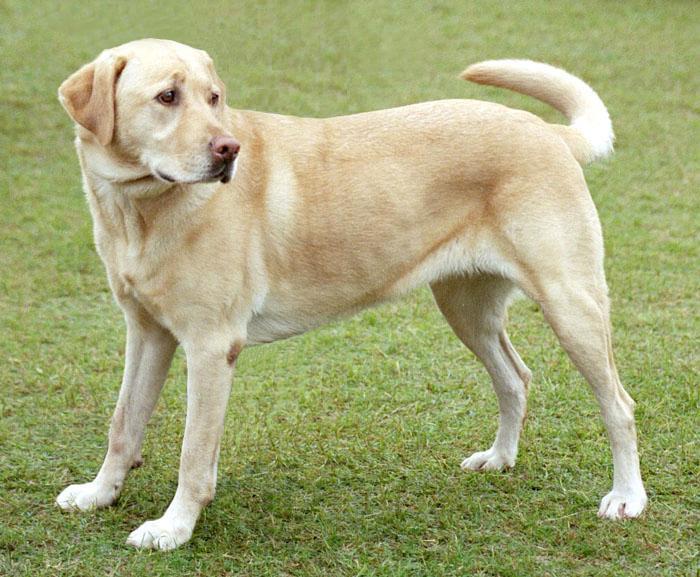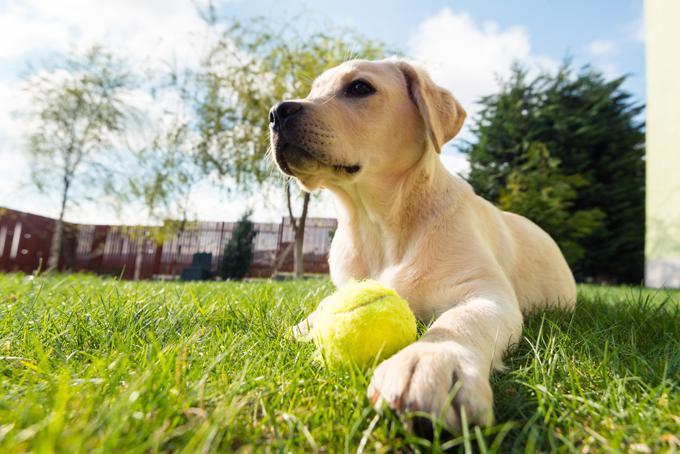The first image is the image on the left, the second image is the image on the right. Considering the images on both sides, is "At least one dog has a green tennis ball." valid? Answer yes or no. Yes. 